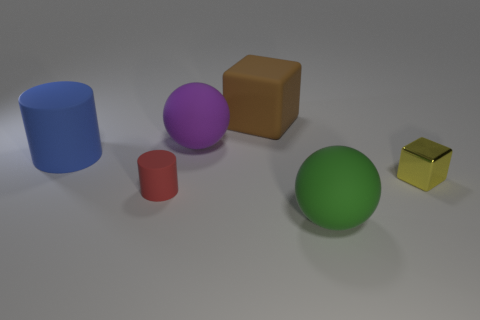Describe the sizes of the objects and how they compare to each other. The objects vary in size. The blue cylinder and green sphere are the largest, followed by the purple sphere, which is slightly smaller. The brown cube is medium-sized, while the tiny red cylinder and the shiny yellow cube are the smallest objects in the image. 